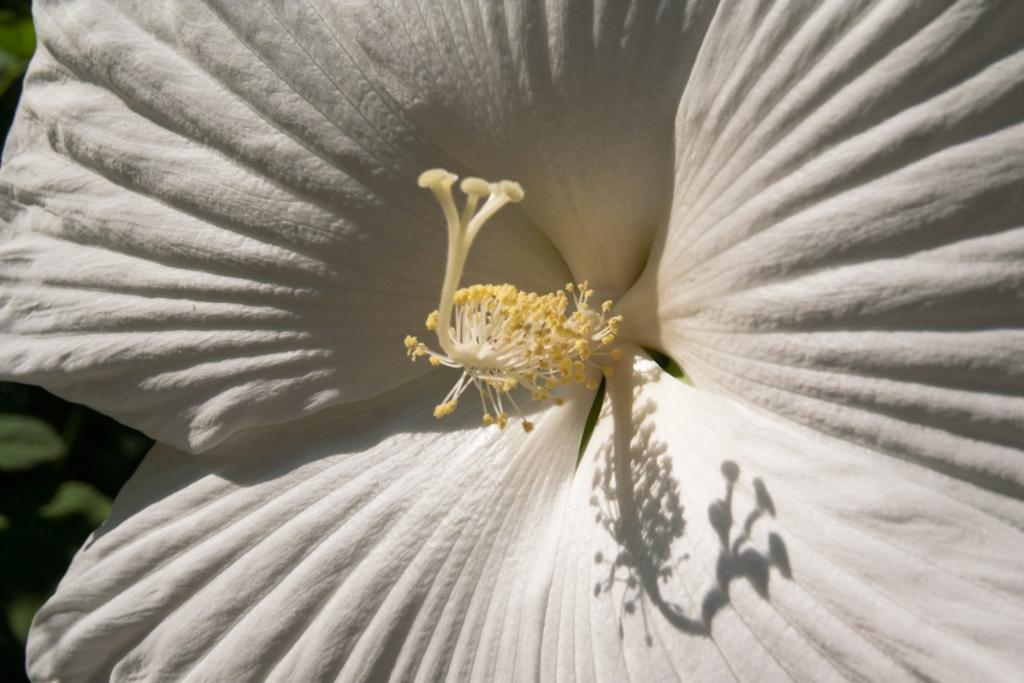What is the main subject of the image? The main subject of the image is a cat. What is the cat doing in the image? The cat is sitting on a chair. What type of guitar is the cat playing in the image? There is no guitar present in the image; the main subject is a cat sitting on a chair. 